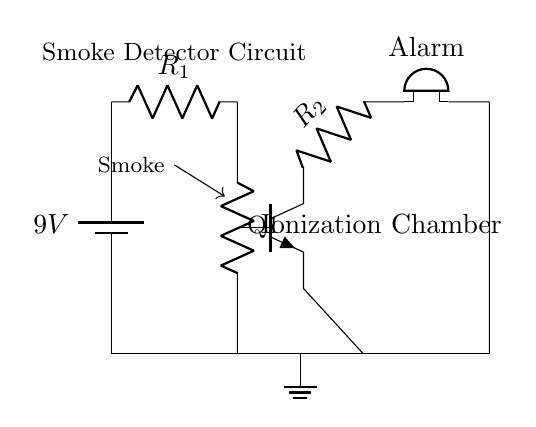What is the voltage in the circuit? The voltage is 9V, as indicated by the battery component labeled with a voltage value of 9V at the beginning of the circuit.
Answer: 9V What does the ionization chamber do? The ionization chamber detects smoke by creating a small electric current when smoke particles interfere with the ionized air within the chamber; this can trigger the alarm.
Answer: Detects smoke What type of transistor is used in this circuit? The circuit shows an NPN transistor, which is identified by the label "npn" near the transistor symbol, indicating its configuration.
Answer: NPN What happens when smoke is detected? Smoke interferes with the current in the ionization chamber, leading to a change in the current that subsequently activates the transistor, which allows current to flow to the alarm.
Answer: Alarm sounds What is the function of resistor R1? R1 limits the current to the ionization chamber, ensuring that the current does not exceed a safe level which helps in maintaining the performance of the smoke detector reliably.
Answer: Current limiting How is the alarm activated in the smoke detector circuit? The alarm is activated when the transistor conducts due to the altered current from the ionization chamber, which supplies enough power to the buzzer, causing it to sound.
Answer: Alarm is powered What role does resistor R2 play in the alarm circuit? R2 is used to control the current flowing to the alarm; it ensures that the buzzer receives the correct voltage and current for proper operation, preventing it from getting damaged.
Answer: Current control 